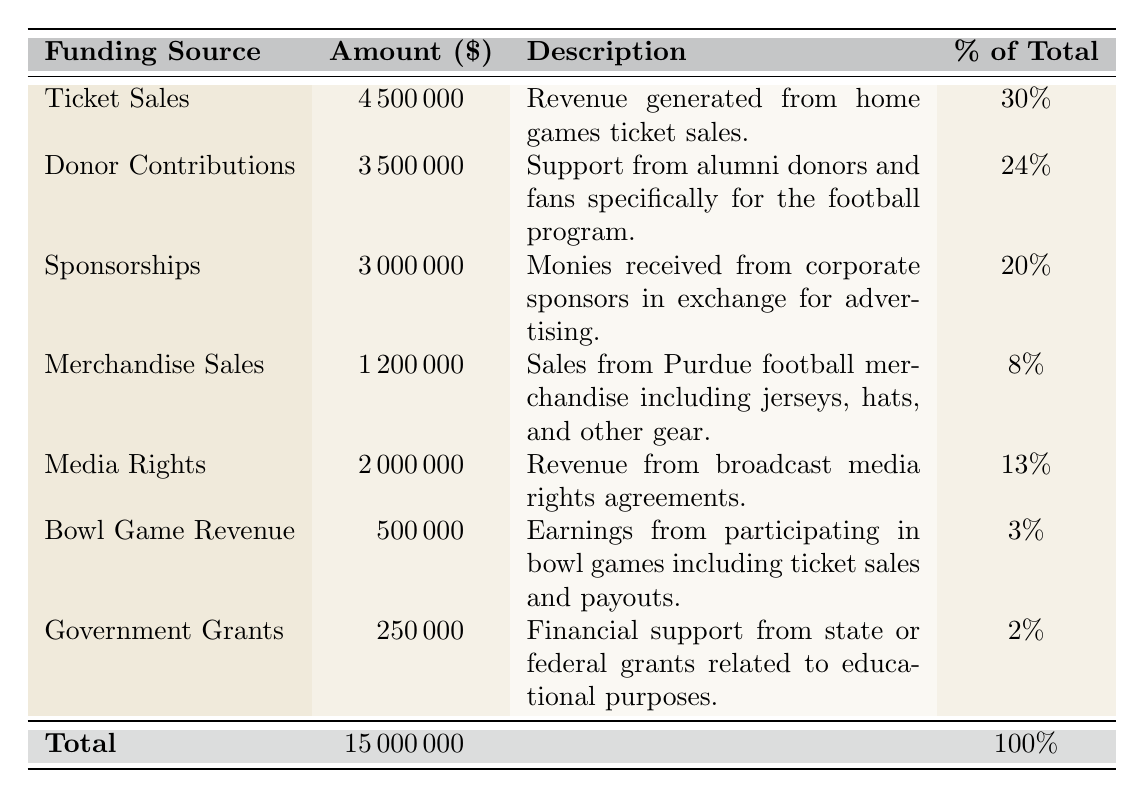What is the total amount of funding for the Purdue football program? The total funding amount is explicitly stated in the table under "Total," which shows $15,000,000.
Answer: 15,000,000 How much revenue comes from Ticket Sales? The amount for Ticket Sales is directly listed in the table as $4,500,000.
Answer: 4,500,000 What percentage of total funding comes from Donor Contributions? The percentage for Donor Contributions is specified in the table as 24%.
Answer: 24% Is the revenue from Government Grants greater than the revenue from Bowl Game Revenue? The amounts for Government Grants ($250,000) and Bowl Game Revenue ($500,000) can be found in the table. Since $250,000 is less than $500,000, the answer is no.
Answer: No What is the combined amount of funding from Media Rights and Merchandise Sales? The amount for Media Rights is $2,000,000 and for Merchandise Sales is $1,200,000. Adding these gives $2,000,000 + $1,200,000 = $3,200,000.
Answer: 3,200,000 What funding source contributes the least to the Purdue football program? The funding source with the smallest amount is listed as Government Grants with $250,000.
Answer: Government Grants Which funding source represents the largest percentage of the total funding? Examining the percentage column, Ticket Sales has the highest percentage at 30%.
Answer: Ticket Sales What is the total revenue from all sources except Merchandise Sales and Government Grants? First, we calculate the total of the other sources: Ticket Sales + Donor Contributions + Sponsorships + Media Rights + Bowl Game Revenue = $4,500,000 + $3,500,000 + $3,000,000 + $2,000,000 + $500,000 = $13,500,000.
Answer: 13,500,000 If the revenues from Sponsorships and Media Rights combined were to decrease by 10%, what would the new total be? The original amounts are Sponsorships $3,000,000 and Media Rights $2,000,000. A 10% decrease would be calculated as: 
Sponsorships: $3,000,000 - ($3,000,000 * 0.10) = $2,700,000
Media Rights: $2,000,000 - ($2,000,000 * 0.10) = $1,800,000
The new total would be $2,700,000 + $1,800,000 = $4,500,000 plus the original total of other sources $13,500,000, equaling $18,000,000.
Answer: 18,000,000 What is the difference in revenue between Donor Contributions and Bowl Game Revenue? The amount for Donor Contributions is $3,500,000, and for Bowl Game Revenue, it is $500,000. The difference is calculated as $3,500,000 - $500,000 = $3,000,000.
Answer: 3,000,000 Is the total funding from sponsorships and bowl game revenue greater than or equal to the total from ticket sales? Sponsorships amount to $3,000,000 and Bowl Game Revenue is $500,000, which combined gives $3,500,000. Ticket Sales amount to $4,500,000. Since $3,500,000 is less than $4,500,000, the answer is no.
Answer: No 